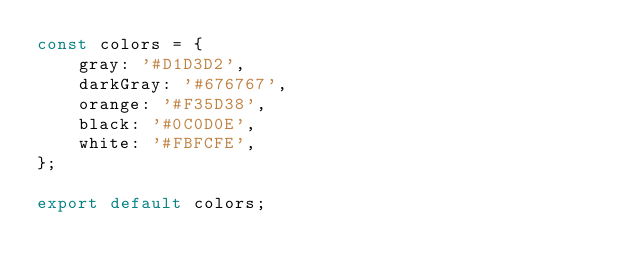<code> <loc_0><loc_0><loc_500><loc_500><_JavaScript_>const colors = {
    gray: '#D1D3D2',
    darkGray: '#676767',
    orange: '#F35D38',
    black: '#0C0D0E',
    white: '#FBFCFE',
};

export default colors;</code> 